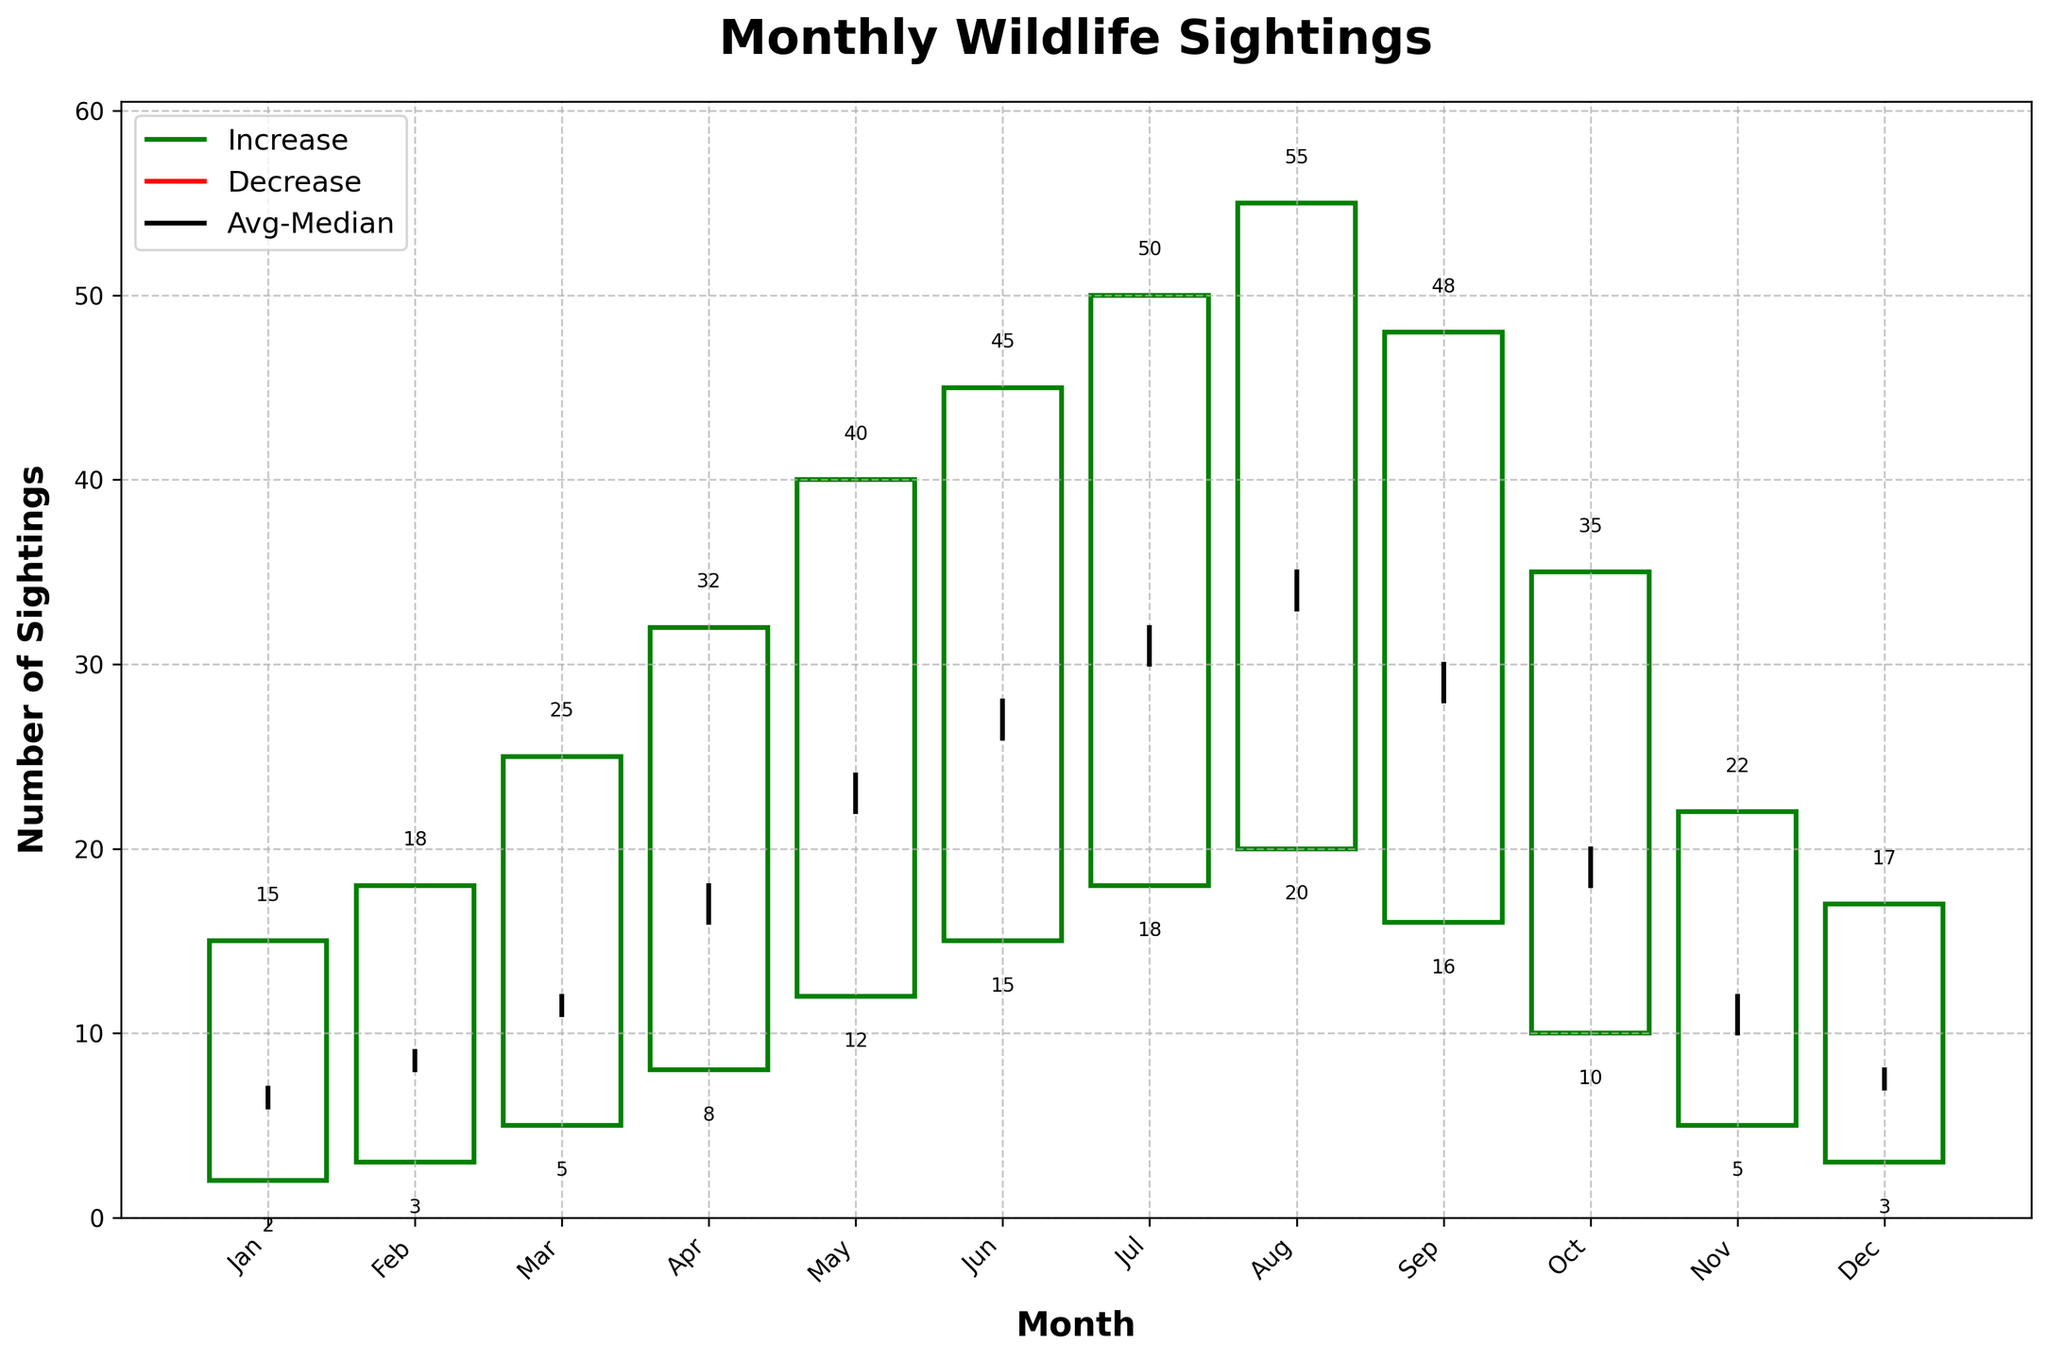What is the title of the figure? The title is usually found at the top of the figure. The title of this specific figure is "Monthly Wildlife Sightings".
Answer: Monthly Wildlife Sightings Which month had the highest number of maximum wildlife sightings? You can identify the highest number of maximum wildlife sightings by looking at the top point of the OHLC bar that is the tallest. The highest maximum value is in August.
Answer: August What is the average daily observation for July? The average daily observation value for each month is represented by a black line. In July, this value is marked at 32.
Answer: 32 Between which months does the maximum number of sightings decrease? You can identify where the maximum sightings decrease by comparing the lengths of the OHLC bars. The maximum number of sightings decreases between July and September.
Answer: July to September How many months have a median value of 10? You need to look at the black line representing the median value and find the months where this value equals 10. The months are February and November.
Answer: 2 Which month has the smallest range of sightings? The range of sightings can be identified by the height of the OHLC bars. The month with the shortest bar height (smallest range) is January.
Answer: January What is the minimum number of wildlife sightings in February? The minimum sightings for a month are represented by the bottom of the OHLC bar. For February, this value is marked as 3.
Answer: 3 Compare the average number of sightings in March and October. Which month is higher and by how much? The average number of sightings for each month is represented by a black line. March has 12 and October has 20. The difference is October - March = 20 - 12 = 8.
Answer: October, by 8 Which month shows the largest difference between the average and median sightings? To determine this, you must look at the black lines representing average and median values and calculate the difference for each month. The largest difference occurs in April, with values of 18 and 16, respectively, giving a difference of 2.
Answer: April, by 2 How many times does the maximum number of sightings column reach or exceed 40 sightings? This is indicated by the height of the OHLC bars. The height reaches or exceeds 40 sightings in May, June, July, and August.
Answer: 4 